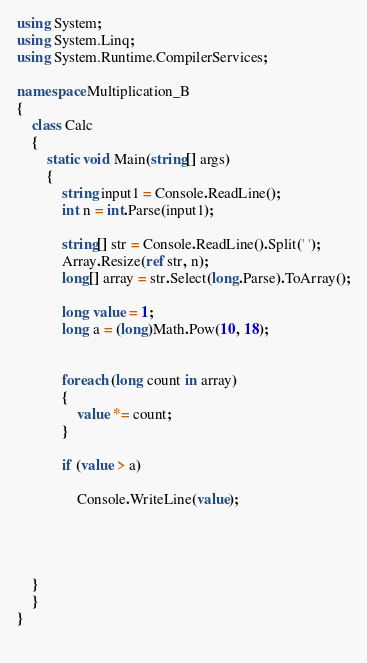<code> <loc_0><loc_0><loc_500><loc_500><_C#_>using System;
using System.Linq;
using System.Runtime.CompilerServices;

namespace Multiplication_B
{
    class Calc
    {
        static void Main(string[] args)
        {
            string input1 = Console.ReadLine();
            int n = int.Parse(input1);

            string[] str = Console.ReadLine().Split(' ');
            Array.Resize(ref str, n);
            long[] array = str.Select(long.Parse).ToArray();

            long value = 1;
            long a = (long)Math.Pow(10, 18);


            foreach (long count in array)
            {
                value *= count;
            }

            if (value > a)
            
                Console.WriteLine(value);
            
           
            

    }
    }
}
           </code> 